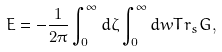<formula> <loc_0><loc_0><loc_500><loc_500>E = - \frac { 1 } { 2 \pi } \int _ { 0 } ^ { \infty } d \zeta \int _ { 0 } ^ { \infty } d w T r _ { s } G ,</formula> 